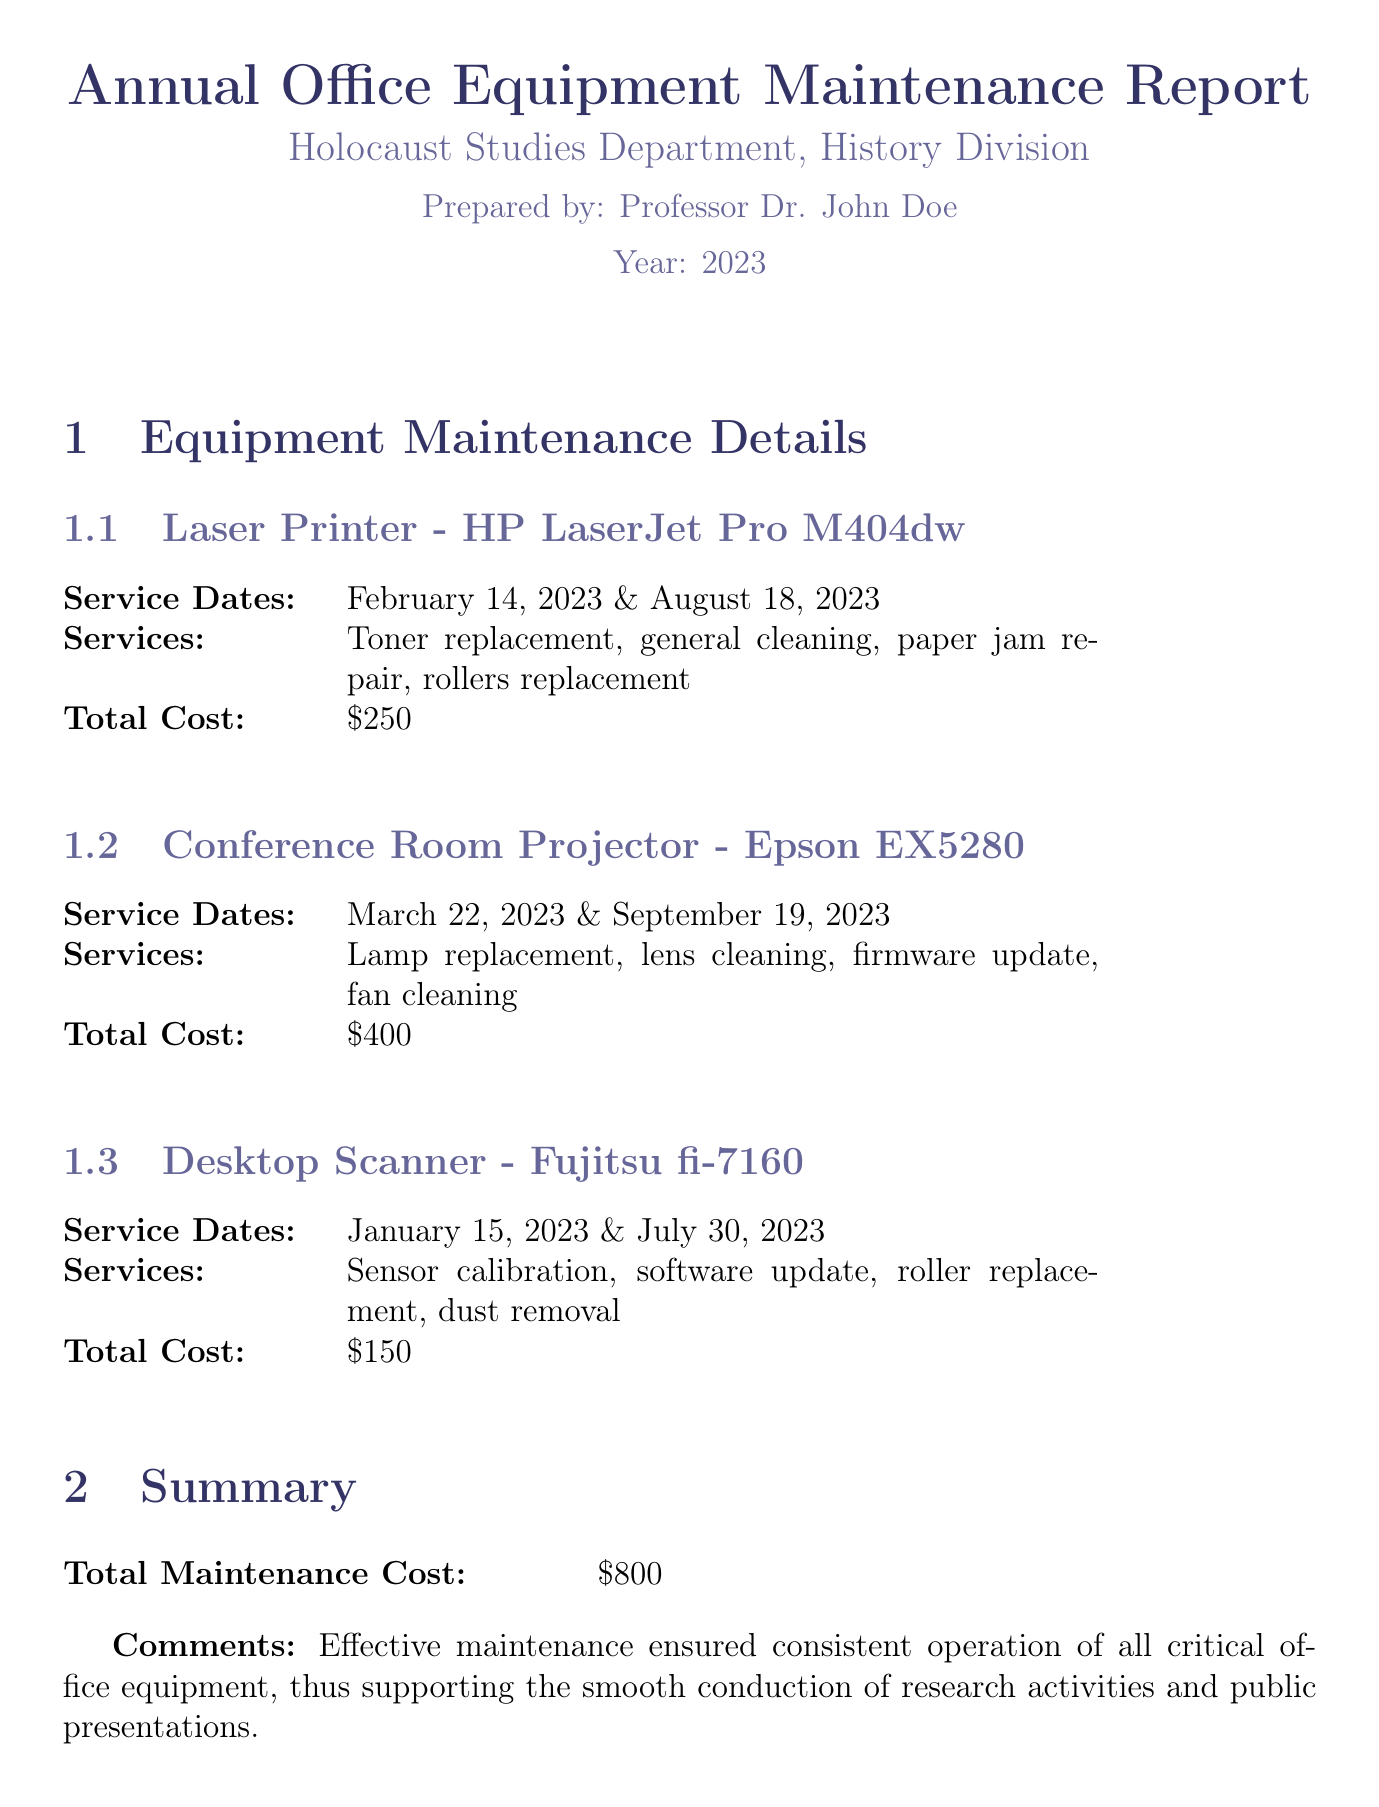What is the total maintenance cost? The total maintenance cost is explicitly listed in the summary of the document.
Answer: $800 When was the last maintenance for the Laser Printer? The last maintenance date for the Laser Printer is found in the service dates section.
Answer: August 18, 2023 How many times was the Conference Room Projector serviced in 2023? The Conference Room Projector entry indicates the number of service dates listed.
Answer: 2 What service was performed on the Desktop Scanner? The type of services performed on the Desktop Scanner is detailed in the services section.
Answer: Sensor calibration, software update, roller replacement, dust removal Who prepared the report? The name of the person who prepared the report is mentioned at the beginning of the document.
Answer: Professor Dr. John Doe What equipment had a service date in January 2023? The service date in January 2023 can be directly referenced from the equipment maintenance details.
Answer: Desktop Scanner - Fujitsu fi-7160 What color is used for the title in the document? The document specifies the RGB color code for the title which indicates its visual representation.
Answer: RGB(51,51,102) What was replaced on the Laser Printer? The services performed on the Laser Printer are enumerated, detailing the actions taken.
Answer: Toner replacement, general cleaning, paper jam repair, rollers replacement 